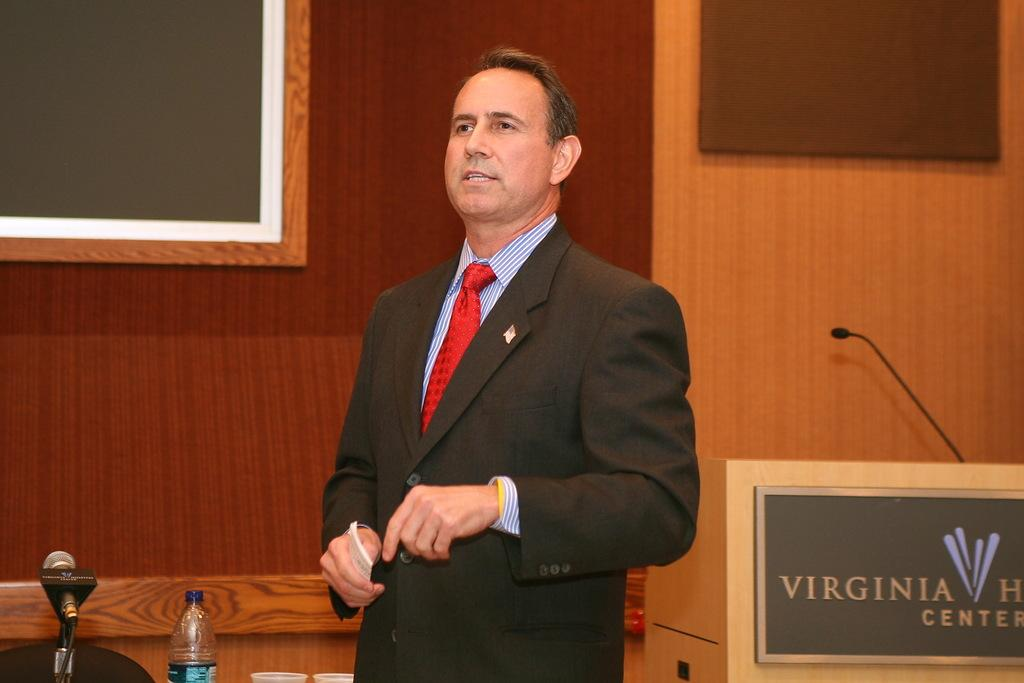Provide a one-sentence caption for the provided image. A man giving a talk next to a lectern that says Virginia something Center. 